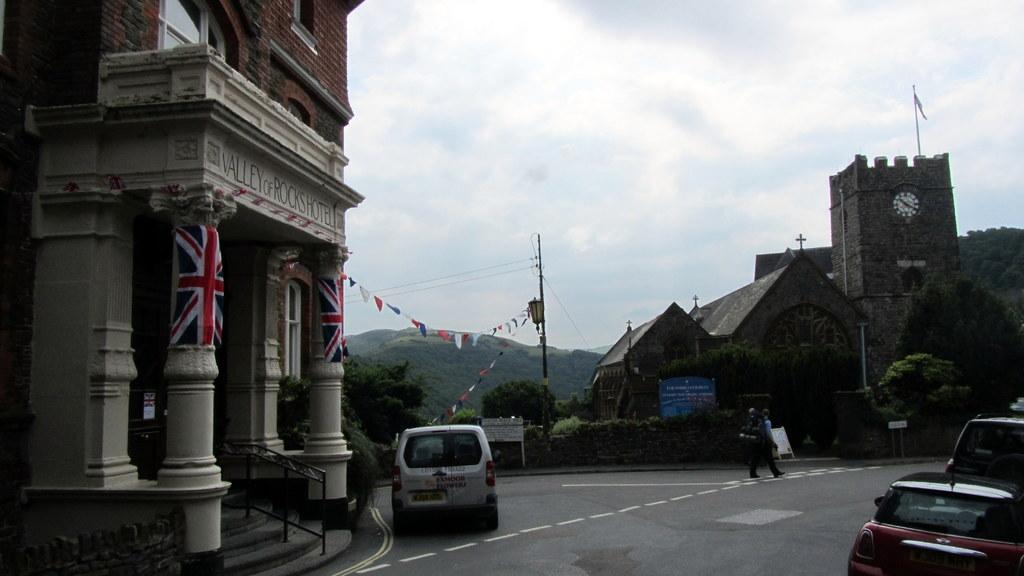<image>
Present a compact description of the photo's key features. The facade of the Valley of Rocks Hotel has the British flag on it. 